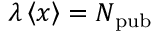<formula> <loc_0><loc_0><loc_500><loc_500>\lambda \left \langle { x } \right \rangle = N _ { p u b }</formula> 